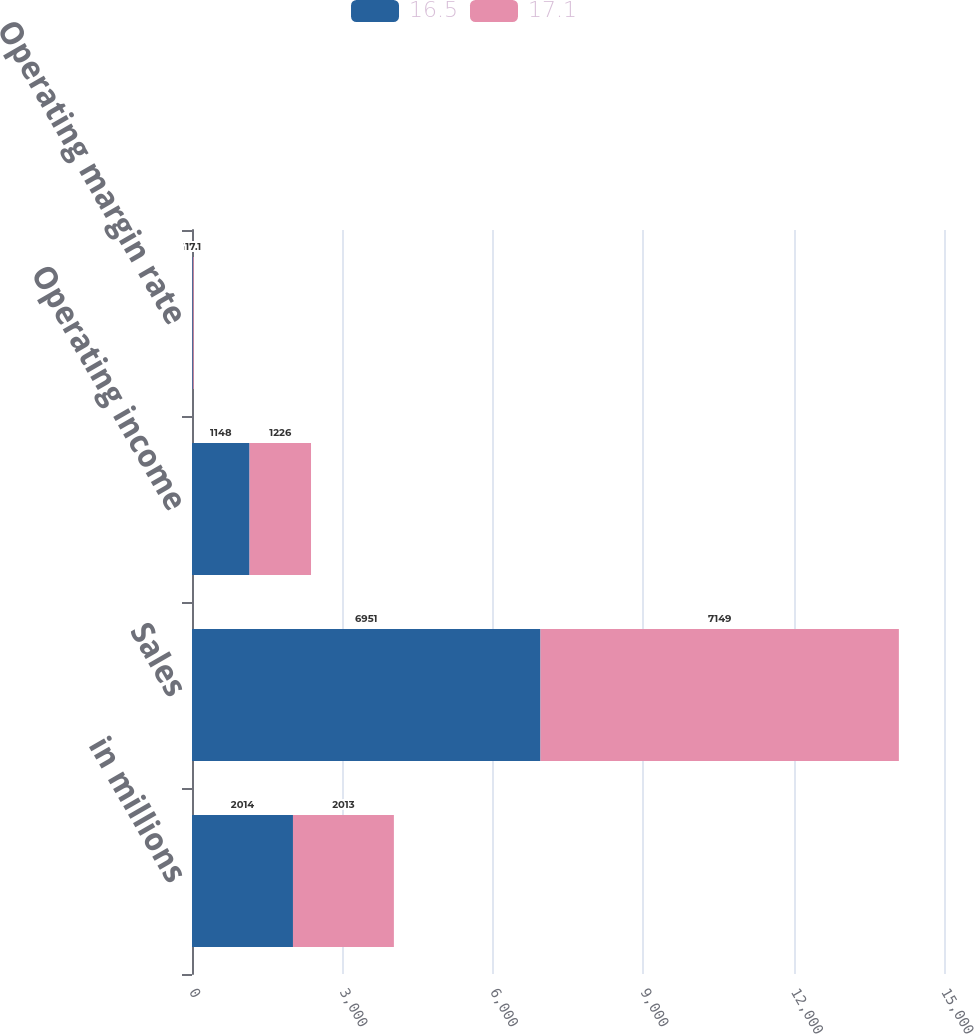Convert chart to OTSL. <chart><loc_0><loc_0><loc_500><loc_500><stacked_bar_chart><ecel><fcel>in millions<fcel>Sales<fcel>Operating income<fcel>Operating margin rate<nl><fcel>16.5<fcel>2014<fcel>6951<fcel>1148<fcel>16.5<nl><fcel>17.1<fcel>2013<fcel>7149<fcel>1226<fcel>17.1<nl></chart> 